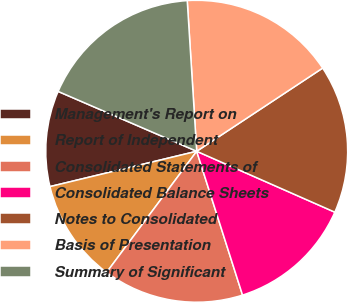<chart> <loc_0><loc_0><loc_500><loc_500><pie_chart><fcel>Management's Report on<fcel>Report of Independent<fcel>Consolidated Statements of<fcel>Consolidated Balance Sheets<fcel>Notes to Consolidated<fcel>Basis of Presentation<fcel>Summary of Significant<nl><fcel>10.25%<fcel>11.06%<fcel>15.09%<fcel>13.48%<fcel>15.9%<fcel>16.71%<fcel>17.51%<nl></chart> 